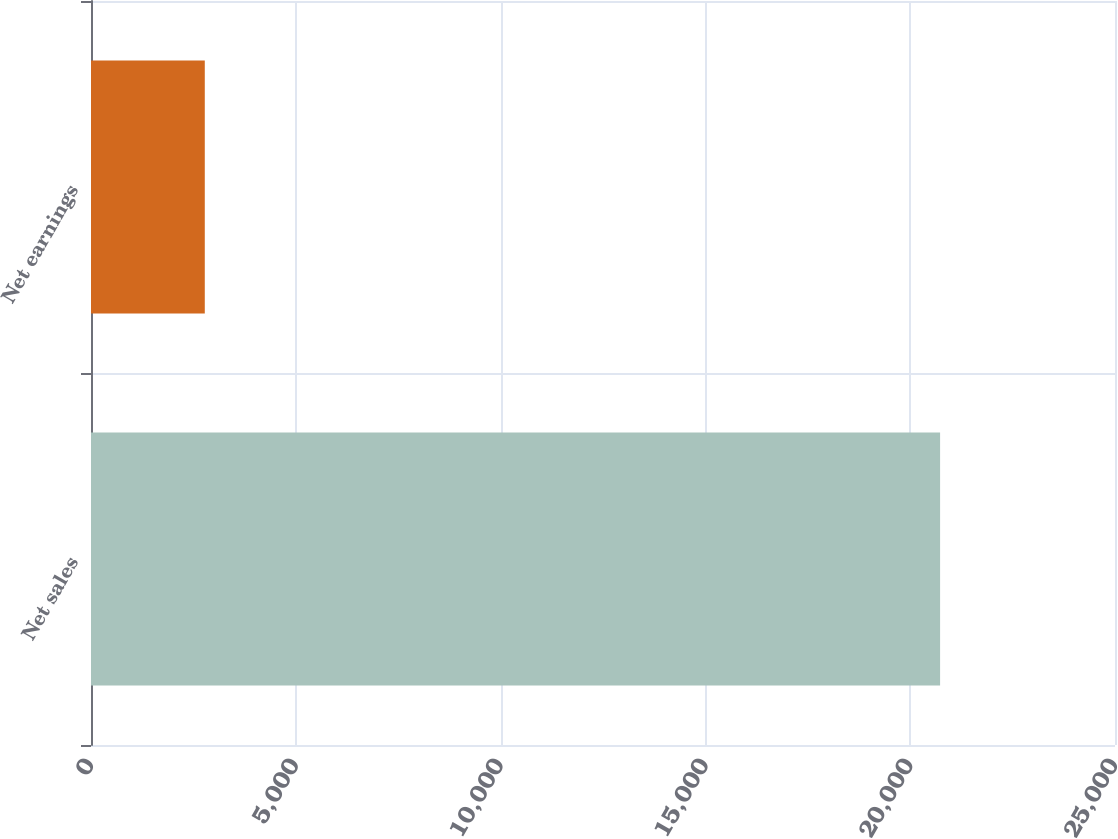Convert chart to OTSL. <chart><loc_0><loc_0><loc_500><loc_500><bar_chart><fcel>Net sales<fcel>Net earnings<nl><fcel>20730<fcel>2778<nl></chart> 